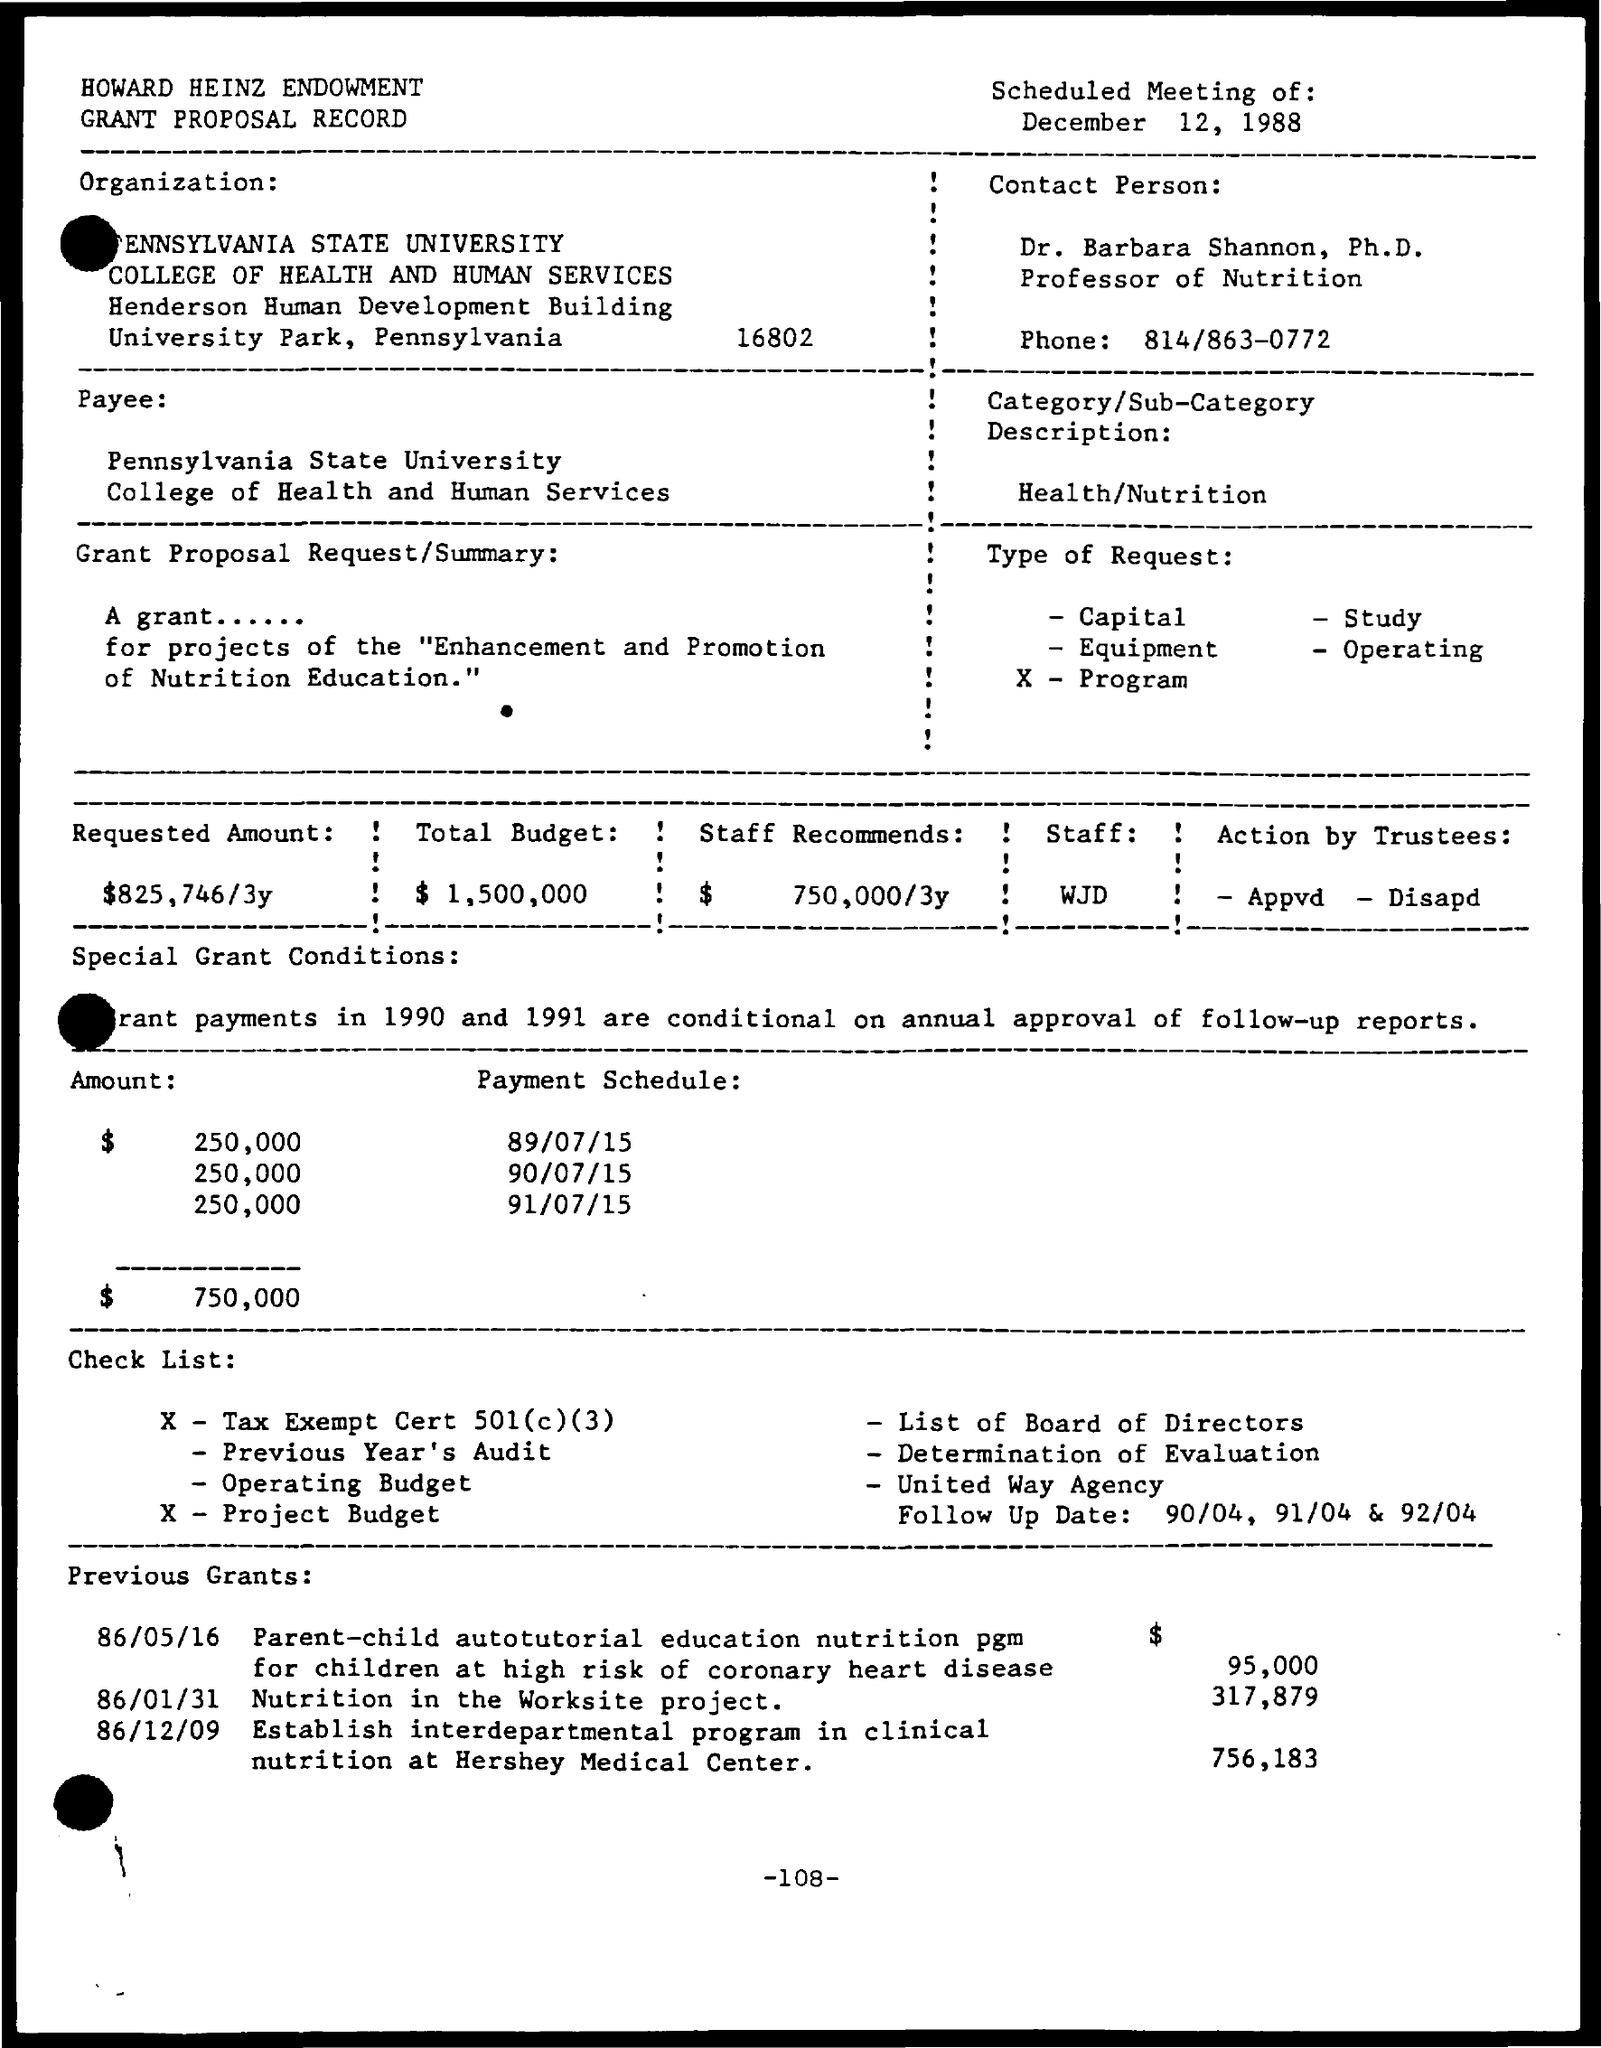What is the phone number of contact person?
Ensure brevity in your answer.  814/863-0772. What is the date scheduled for meeting?
Your response must be concise. December 12, 1988. What is the requested amount?
Give a very brief answer. $825,746/3y. What is the total budget?
Your answer should be very brief. $1,500,000. What is the amount that staff recommends?
Your answer should be compact. $750,000/3y. What was previous grant for nutrition in the worksite project?
Give a very brief answer. $317,879. 